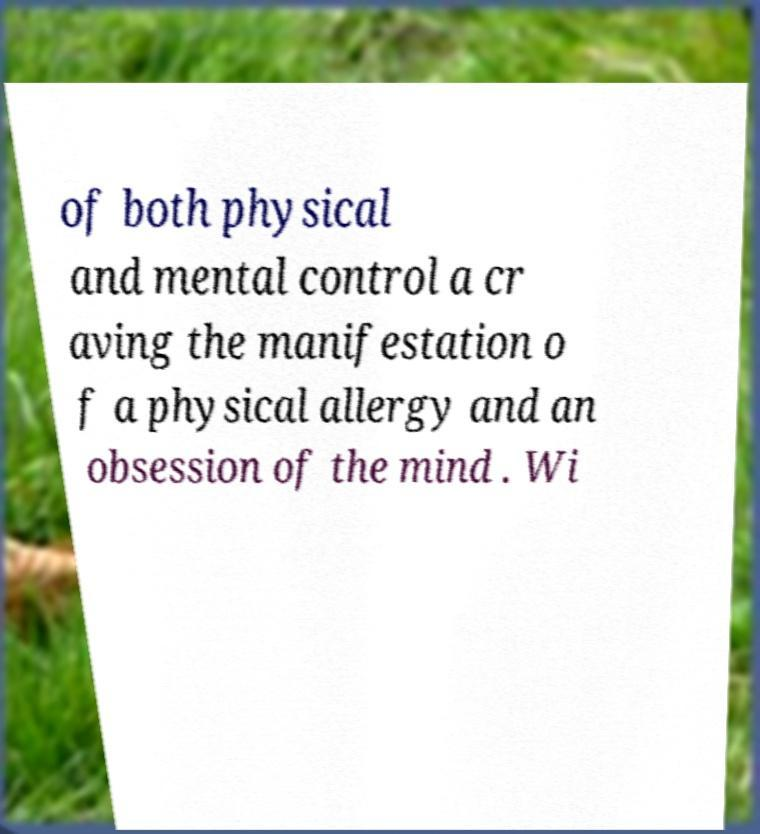Please identify and transcribe the text found in this image. of both physical and mental control a cr aving the manifestation o f a physical allergy and an obsession of the mind . Wi 